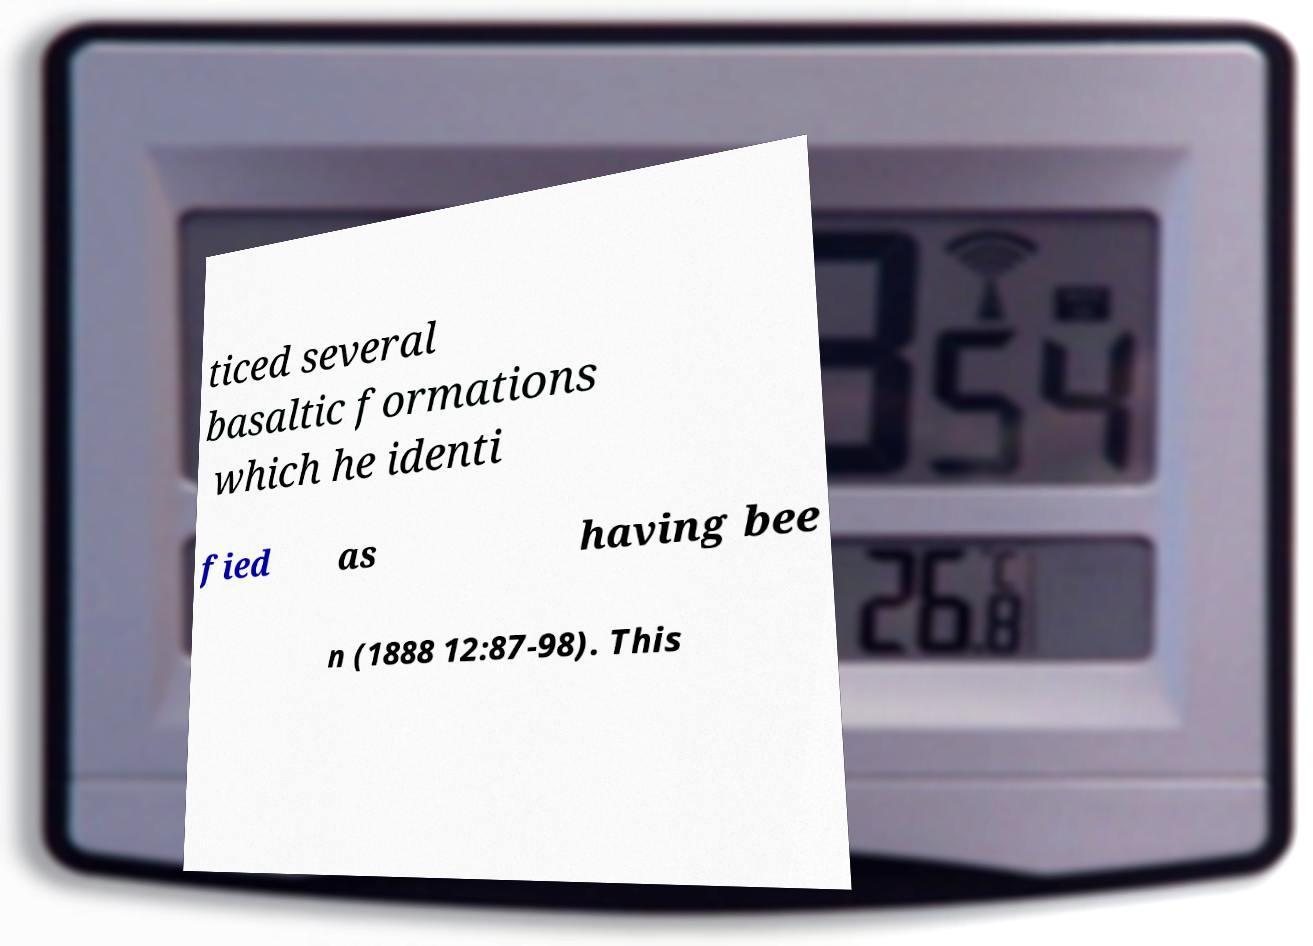Can you read and provide the text displayed in the image?This photo seems to have some interesting text. Can you extract and type it out for me? ticed several basaltic formations which he identi fied as having bee n (1888 12:87-98). This 